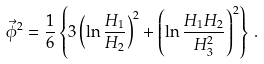<formula> <loc_0><loc_0><loc_500><loc_500>\vec { \phi } ^ { 2 } = \frac { 1 } { 6 } \left \{ 3 \left ( \ln \frac { H _ { 1 } } { H _ { 2 } } \right ) ^ { 2 } + \left ( \ln \frac { H _ { 1 } H _ { 2 } } { H _ { 3 } ^ { 2 } } \right ) ^ { 2 } \right \} \, .</formula> 